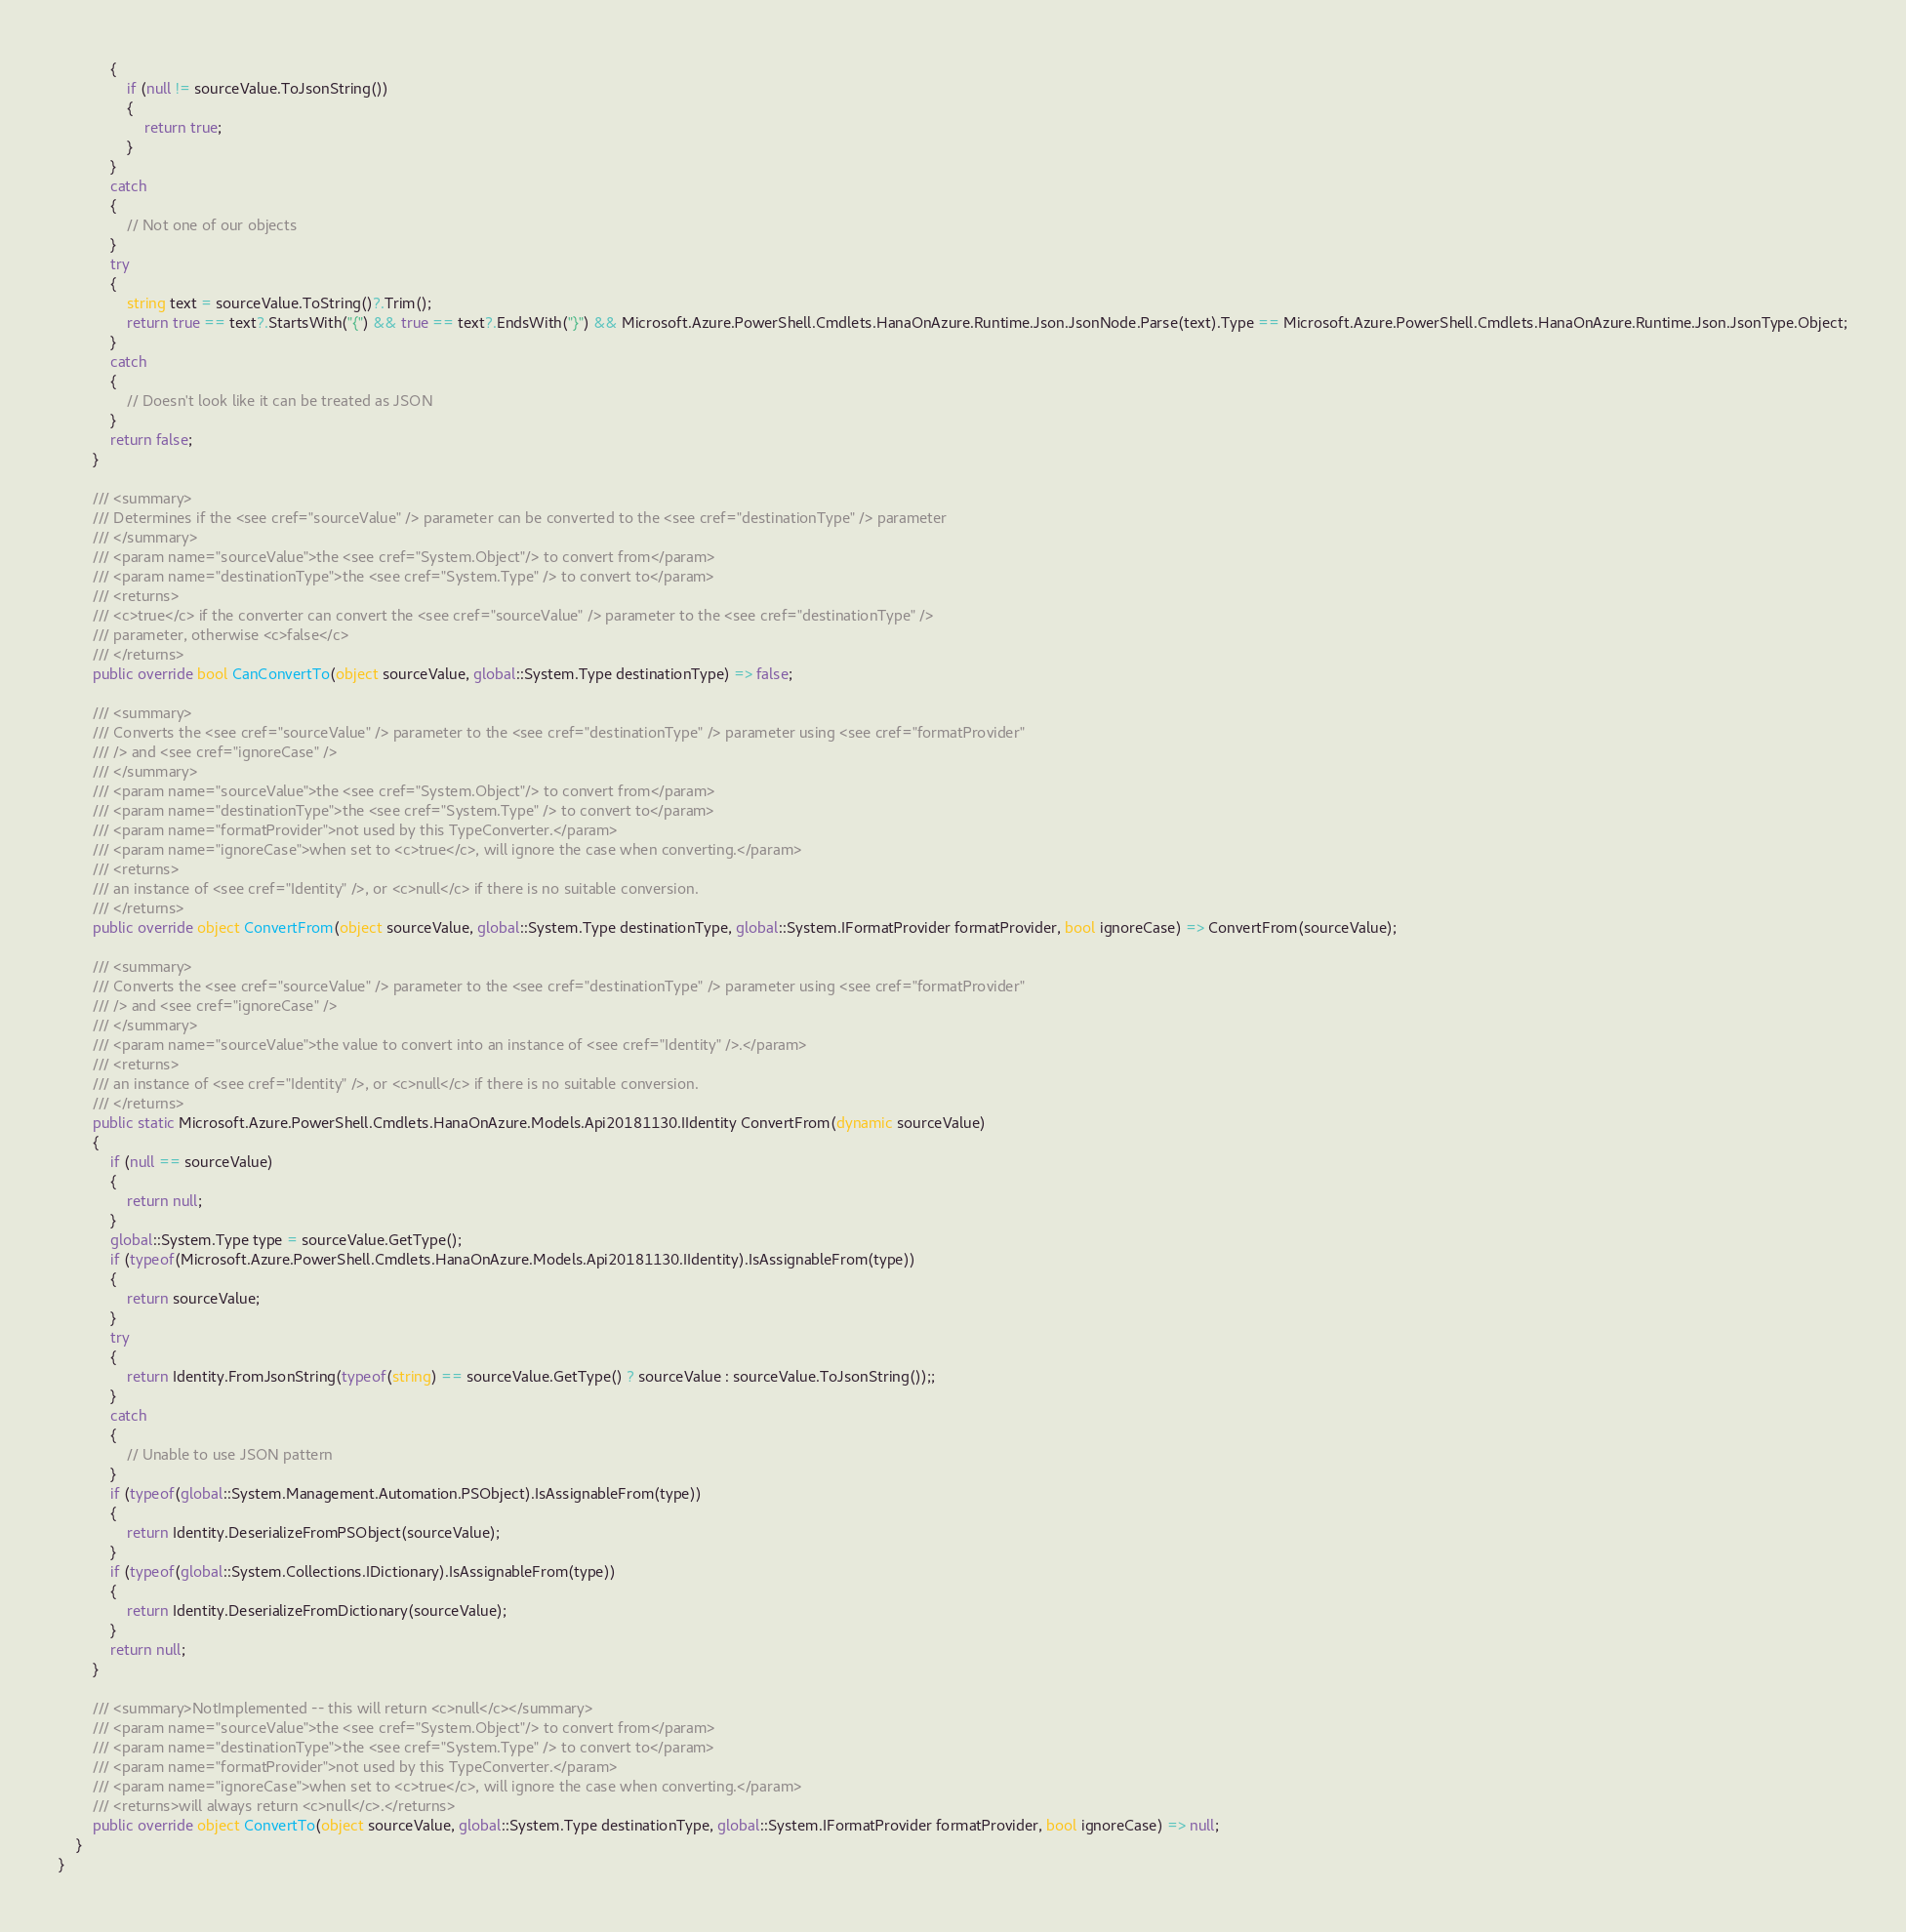Convert code to text. <code><loc_0><loc_0><loc_500><loc_500><_C#_>            {
                if (null != sourceValue.ToJsonString())
                {
                    return true;
                }
            }
            catch
            {
                // Not one of our objects
            }
            try
            {
                string text = sourceValue.ToString()?.Trim();
                return true == text?.StartsWith("{") && true == text?.EndsWith("}") && Microsoft.Azure.PowerShell.Cmdlets.HanaOnAzure.Runtime.Json.JsonNode.Parse(text).Type == Microsoft.Azure.PowerShell.Cmdlets.HanaOnAzure.Runtime.Json.JsonType.Object;
            }
            catch
            {
                // Doesn't look like it can be treated as JSON
            }
            return false;
        }

        /// <summary>
        /// Determines if the <see cref="sourceValue" /> parameter can be converted to the <see cref="destinationType" /> parameter
        /// </summary>
        /// <param name="sourceValue">the <see cref="System.Object"/> to convert from</param>
        /// <param name="destinationType">the <see cref="System.Type" /> to convert to</param>
        /// <returns>
        /// <c>true</c> if the converter can convert the <see cref="sourceValue" /> parameter to the <see cref="destinationType" />
        /// parameter, otherwise <c>false</c>
        /// </returns>
        public override bool CanConvertTo(object sourceValue, global::System.Type destinationType) => false;

        /// <summary>
        /// Converts the <see cref="sourceValue" /> parameter to the <see cref="destinationType" /> parameter using <see cref="formatProvider"
        /// /> and <see cref="ignoreCase" />
        /// </summary>
        /// <param name="sourceValue">the <see cref="System.Object"/> to convert from</param>
        /// <param name="destinationType">the <see cref="System.Type" /> to convert to</param>
        /// <param name="formatProvider">not used by this TypeConverter.</param>
        /// <param name="ignoreCase">when set to <c>true</c>, will ignore the case when converting.</param>
        /// <returns>
        /// an instance of <see cref="Identity" />, or <c>null</c> if there is no suitable conversion.
        /// </returns>
        public override object ConvertFrom(object sourceValue, global::System.Type destinationType, global::System.IFormatProvider formatProvider, bool ignoreCase) => ConvertFrom(sourceValue);

        /// <summary>
        /// Converts the <see cref="sourceValue" /> parameter to the <see cref="destinationType" /> parameter using <see cref="formatProvider"
        /// /> and <see cref="ignoreCase" />
        /// </summary>
        /// <param name="sourceValue">the value to convert into an instance of <see cref="Identity" />.</param>
        /// <returns>
        /// an instance of <see cref="Identity" />, or <c>null</c> if there is no suitable conversion.
        /// </returns>
        public static Microsoft.Azure.PowerShell.Cmdlets.HanaOnAzure.Models.Api20181130.IIdentity ConvertFrom(dynamic sourceValue)
        {
            if (null == sourceValue)
            {
                return null;
            }
            global::System.Type type = sourceValue.GetType();
            if (typeof(Microsoft.Azure.PowerShell.Cmdlets.HanaOnAzure.Models.Api20181130.IIdentity).IsAssignableFrom(type))
            {
                return sourceValue;
            }
            try
            {
                return Identity.FromJsonString(typeof(string) == sourceValue.GetType() ? sourceValue : sourceValue.ToJsonString());;
            }
            catch
            {
                // Unable to use JSON pattern
            }
            if (typeof(global::System.Management.Automation.PSObject).IsAssignableFrom(type))
            {
                return Identity.DeserializeFromPSObject(sourceValue);
            }
            if (typeof(global::System.Collections.IDictionary).IsAssignableFrom(type))
            {
                return Identity.DeserializeFromDictionary(sourceValue);
            }
            return null;
        }

        /// <summary>NotImplemented -- this will return <c>null</c></summary>
        /// <param name="sourceValue">the <see cref="System.Object"/> to convert from</param>
        /// <param name="destinationType">the <see cref="System.Type" /> to convert to</param>
        /// <param name="formatProvider">not used by this TypeConverter.</param>
        /// <param name="ignoreCase">when set to <c>true</c>, will ignore the case when converting.</param>
        /// <returns>will always return <c>null</c>.</returns>
        public override object ConvertTo(object sourceValue, global::System.Type destinationType, global::System.IFormatProvider formatProvider, bool ignoreCase) => null;
    }
}</code> 